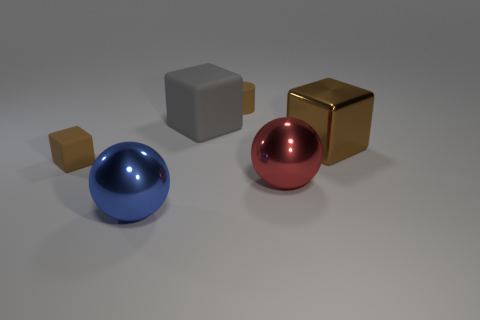Add 3 blue objects. How many objects exist? 9 Subtract all spheres. How many objects are left? 4 Add 4 large green matte blocks. How many large green matte blocks exist? 4 Subtract 0 purple cylinders. How many objects are left? 6 Subtract all small purple cubes. Subtract all tiny brown matte objects. How many objects are left? 4 Add 6 small brown rubber objects. How many small brown rubber objects are left? 8 